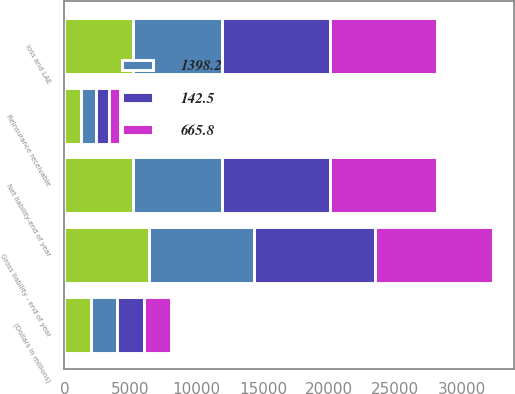Convert chart. <chart><loc_0><loc_0><loc_500><loc_500><stacked_bar_chart><ecel><fcel>(Dollars in millions)<fcel>loss and LAE<fcel>Gross liability - end of year<fcel>Reinsurance receivable<fcel>Net liability-end of year<nl><fcel>nan<fcel>2003<fcel>5158.4<fcel>6424.7<fcel>1266.3<fcel>5158.4<nl><fcel>1398.2<fcel>2004<fcel>6766.9<fcel>7886.6<fcel>1119.6<fcel>6766.9<nl><fcel>142.5<fcel>2005<fcel>8175.4<fcel>9175.1<fcel>999.7<fcel>8175.4<nl><fcel>665.8<fcel>2006<fcel>8078.9<fcel>8888<fcel>809.1<fcel>8078.9<nl></chart> 